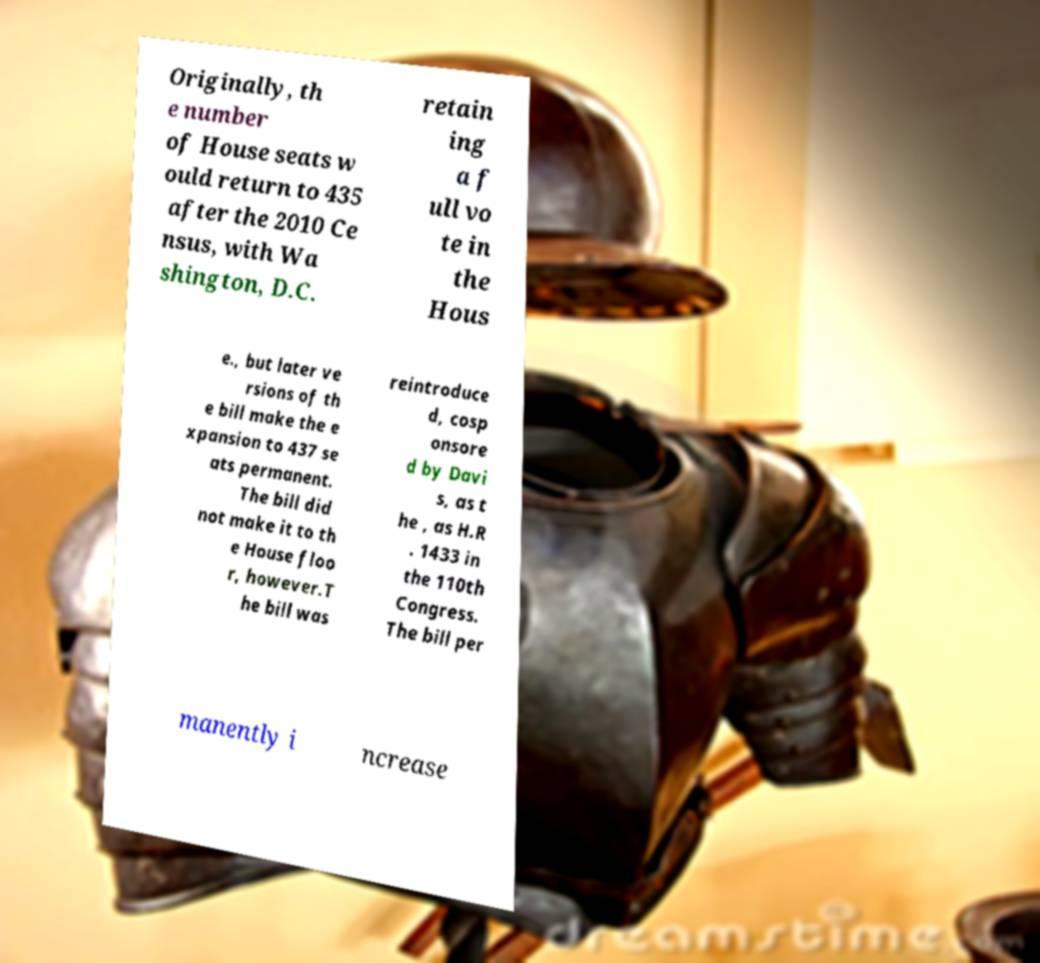What messages or text are displayed in this image? I need them in a readable, typed format. Originally, th e number of House seats w ould return to 435 after the 2010 Ce nsus, with Wa shington, D.C. retain ing a f ull vo te in the Hous e., but later ve rsions of th e bill make the e xpansion to 437 se ats permanent. The bill did not make it to th e House floo r, however.T he bill was reintroduce d, cosp onsore d by Davi s, as t he , as H.R . 1433 in the 110th Congress. The bill per manently i ncrease 